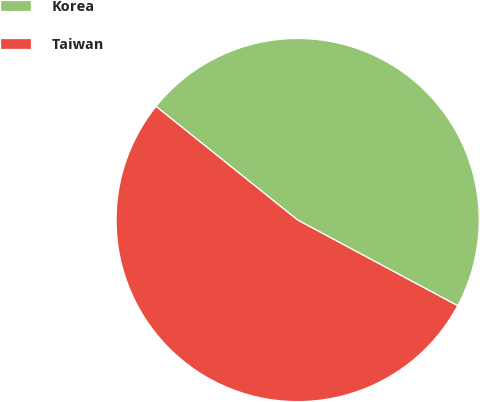Convert chart to OTSL. <chart><loc_0><loc_0><loc_500><loc_500><pie_chart><fcel>Korea<fcel>Taiwan<nl><fcel>47.06%<fcel>52.94%<nl></chart> 